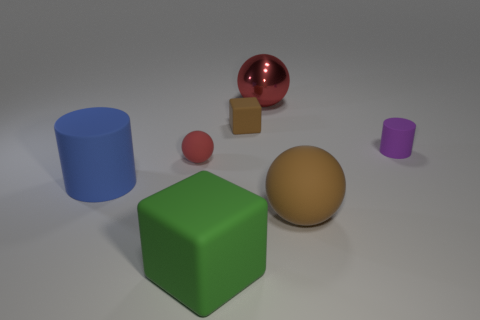What material is the large thing that is the same color as the tiny ball?
Your answer should be compact. Metal. Does the big metal object have the same color as the small matte thing that is to the left of the small cube?
Offer a terse response. Yes. Do the tiny cylinder and the red ball to the right of the large cube have the same material?
Your response must be concise. No. The tiny matte sphere has what color?
Ensure brevity in your answer.  Red. There is a large thing left of the matte ball that is on the left side of the big object that is behind the blue rubber cylinder; what is its color?
Your response must be concise. Blue. Is the shape of the blue thing the same as the small matte object that is on the right side of the big red thing?
Your answer should be compact. Yes. There is a ball that is both in front of the purple rubber thing and behind the large blue matte cylinder; what is its color?
Ensure brevity in your answer.  Red. Are there any big brown rubber things of the same shape as the large red metal object?
Provide a succinct answer. Yes. Is the color of the tiny matte ball the same as the large shiny ball?
Provide a succinct answer. Yes. Are there any brown things on the right side of the red thing behind the purple matte object?
Ensure brevity in your answer.  Yes. 